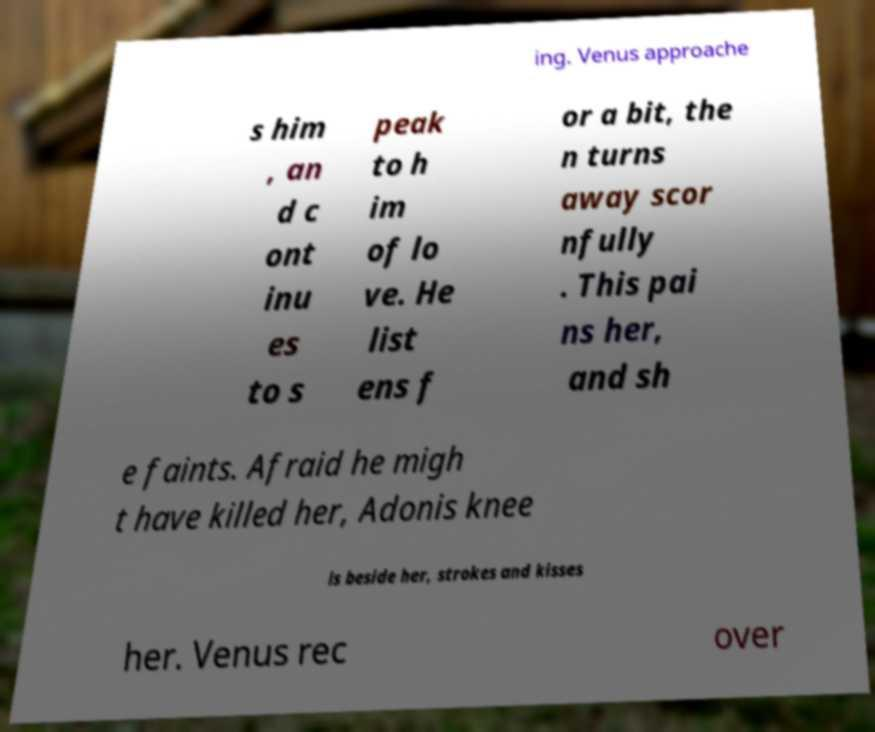Please read and relay the text visible in this image. What does it say? ing. Venus approache s him , an d c ont inu es to s peak to h im of lo ve. He list ens f or a bit, the n turns away scor nfully . This pai ns her, and sh e faints. Afraid he migh t have killed her, Adonis knee ls beside her, strokes and kisses her. Venus rec over 